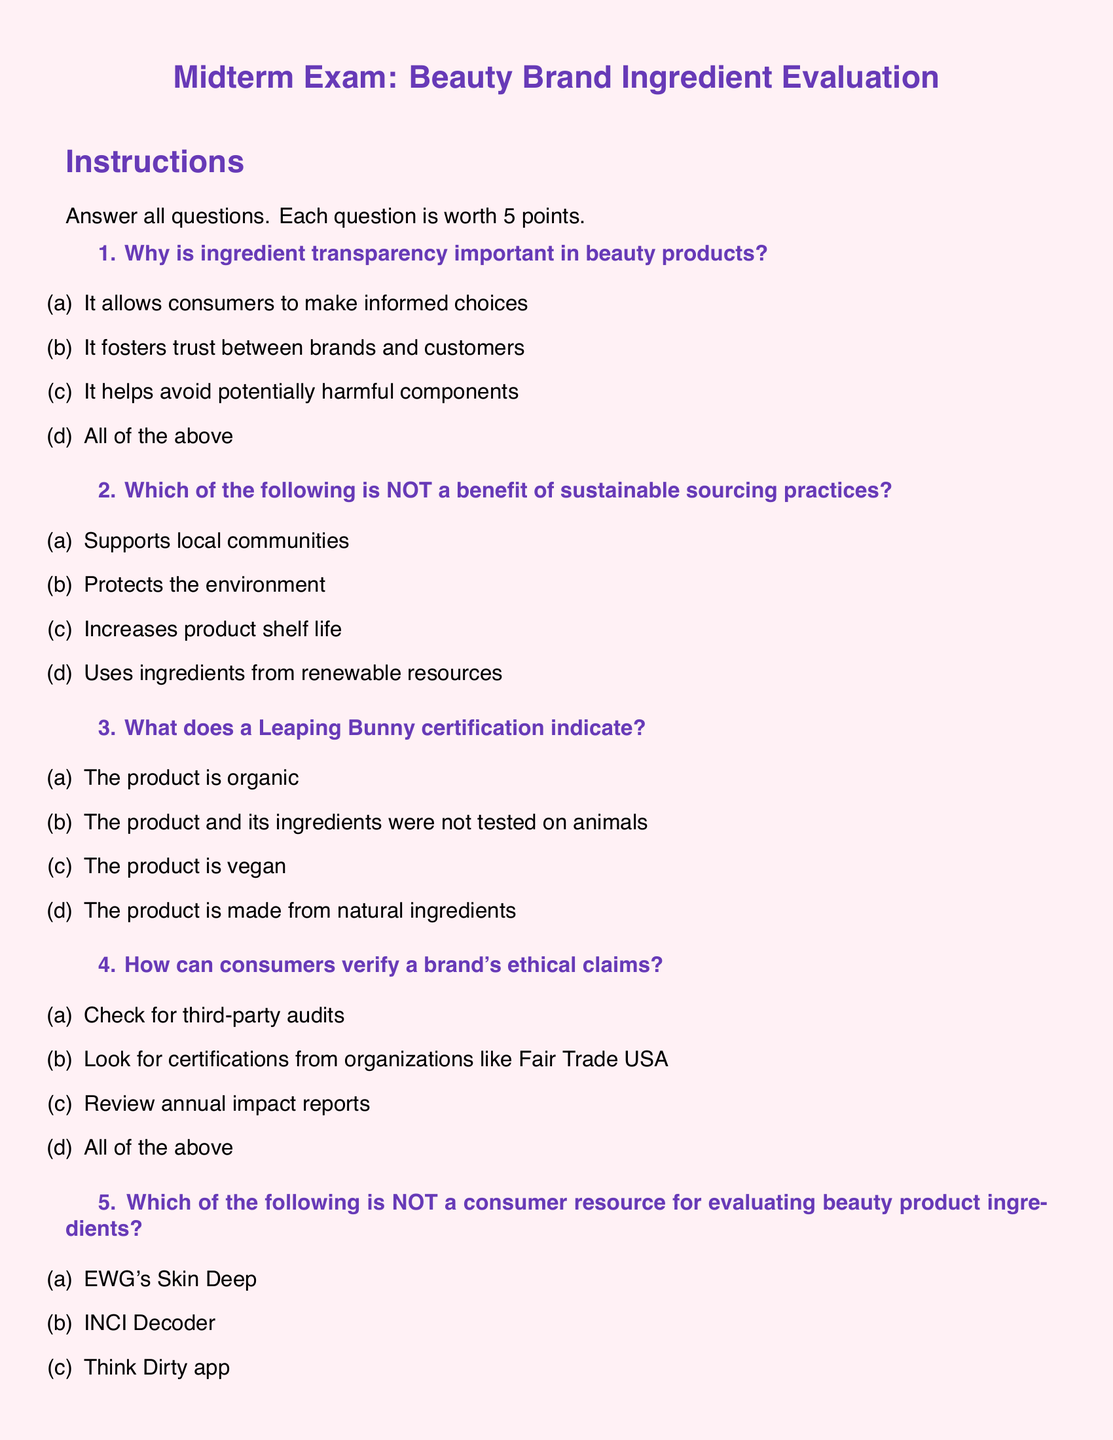What is the title of the exam? The title of the exam is clearly stated at the beginning of the document, which is "Midterm Exam: Beauty Brand Ingredient Evaluation."
Answer: Midterm Exam: Beauty Brand Ingredient Evaluation How many points is each question worth? Each question in the exam is worth 5 points, as specified in the instructions.
Answer: 5 points What does a Leaping Bunny certification indicate? The multiple choice options include the correct answer, which states that a Leaping Bunny certification indicates that the product and its ingredients were not tested on animals.
Answer: Not tested on animals Which question number addresses the importance of understanding ingredient lists? The question focusing on the understanding of ingredient lists is labeled as question number 6.
Answer: 6 What are consumers advised to look for to verify a brand's ethical claims? The document lists several options, with the correct answer being that consumers should check for third-party audits, as mentioned in question 4.
Answer: Third-party audits What is one of the ethical claims consumers should verify? One of the ethical claims consumers should verify is certifications from organizations like Fair Trade USA, which is mentioned in question 4.
Answer: Fair Trade USA In what type of questions do students explain the impact of supporting ethical beauty brands? The questions that request students to explain impacts are categorized as "Short Answer" questions, specifically question 7.
Answer: Short Answer Which resource is NOT mentioned as a consumer resource for evaluating beauty product ingredients? The multiple-choice options indicate that BeautyCounter is the option that is NOT listed as a resource for evaluating beauty product ingredients in question 5.
Answer: BeautyCounter 